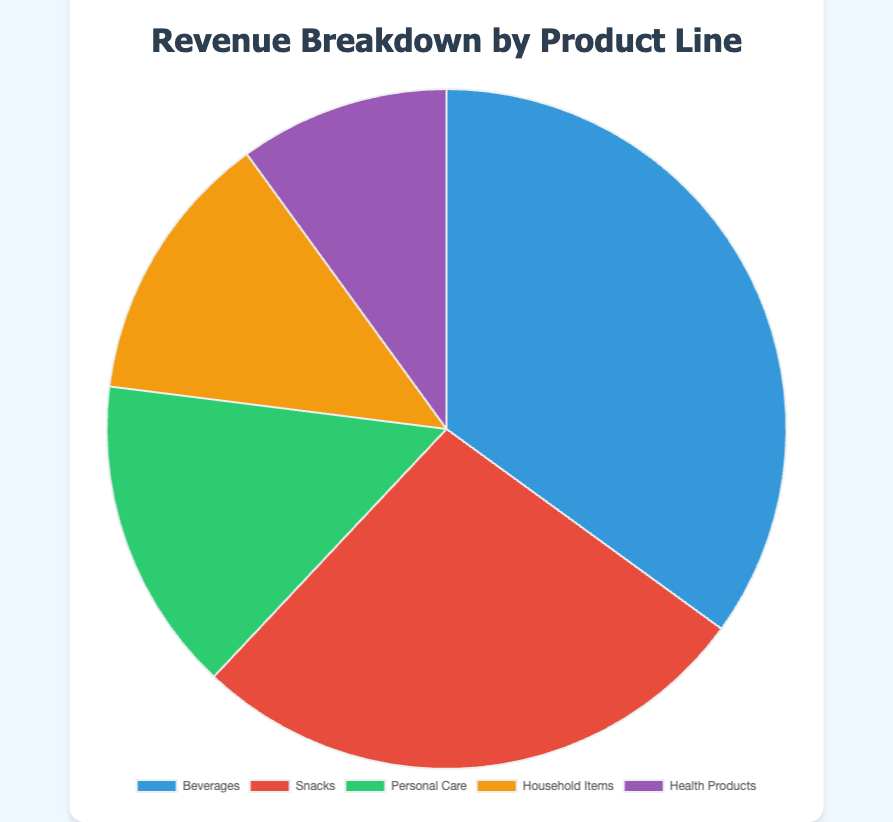Which product line generates the highest revenue? The "Beverages" segment shows the highest revenue with $350,000 depicted in the chart. Therefore, "Beverages" is at the top.
Answer: Beverages What is the total revenue generated by Snacks and Health Products? To find the total revenue, sum up the revenue from "Snacks" ($270,000) and "Health Products" ($100,000). Therefore, $270,000 + $100,000 = $370,000.
Answer: $370,000 Which two product lines combined have a lower revenue than Beverages alone? The product lines with lower revenue compared to "Beverages" ($350,000) are "Personal Care" ($150,000), "Household Items" ($130,000), and "Health Products" ($100,000). Summing two product lines from these options to get the total lower than $350,000. For "Personal Care" and "Household Items", $150,000 + $130,000 = $280,000, which is less than $350,000. For "Personal Care" and "Health Products", $150,000 + $100,000 = $250,000, which is less than $350,000. For "Household Items" and "Health Products", $130,000 + $100,000 = $230,000, which is less than $350,000. Thus, any combination will work.
Answer: Personal Care and Household Items / Personal Care and Health Products / Household Items and Health Products What percentage of the total revenue is generated by Household Items? The total revenue is $350,000 + $270,000 + $150,000 + $130,000 + $100,000 = $1,000,000. The percentage for "Household Items" is calculated as ($130,000 / $1,000,000) * 100 = 13%.
Answer: 13% How does the revenue of Snacks compare to Personal Care? "Snacks" generates $270,000, and "Personal Care" generates $150,000. Since $270,000 is greater than $150,000, "Snacks" generates more revenue.
Answer: Snacks generates more Which product line has the smallest share of the total revenue? "Health Products" has the smallest revenue of $100,000, making it the smallest share in the pie chart.
Answer: Health Products 